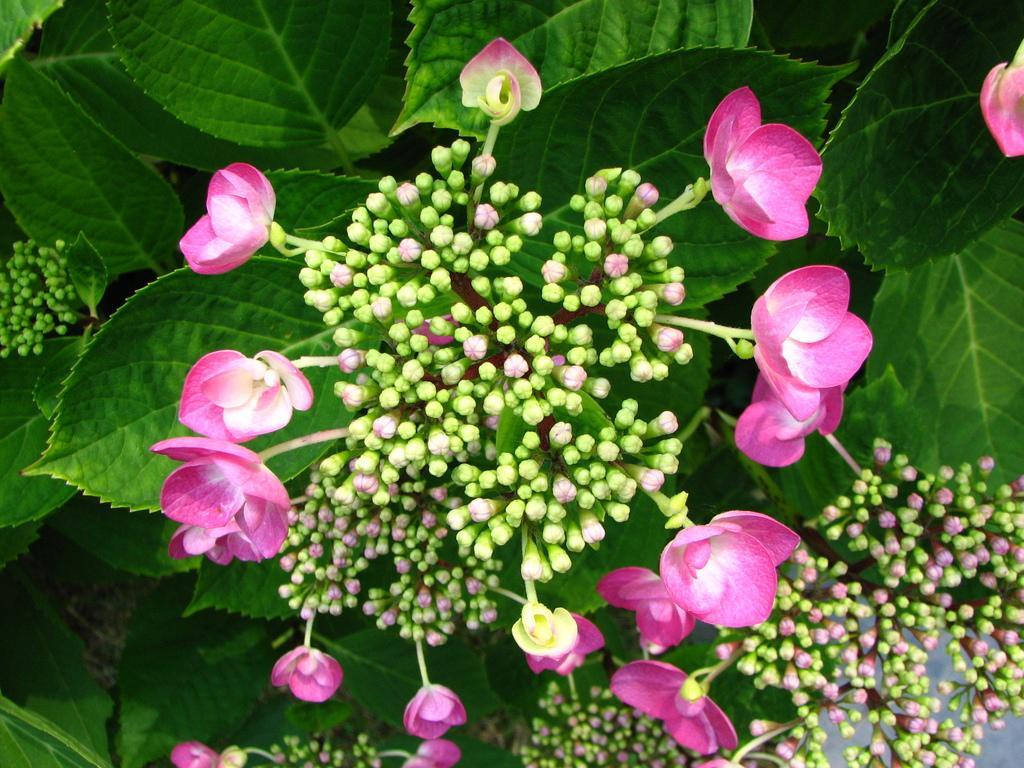Please provide a concise description of this image. There are buds and flowers of a plant in the foreground area of the image, there are leaves in the background. 